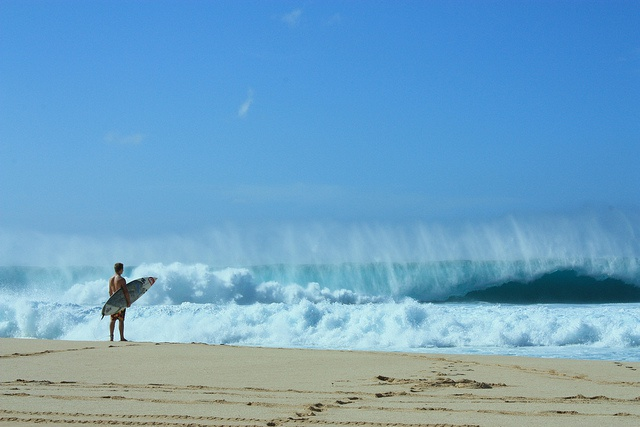Describe the objects in this image and their specific colors. I can see surfboard in gray, black, purple, and darkblue tones and people in gray, black, and maroon tones in this image. 